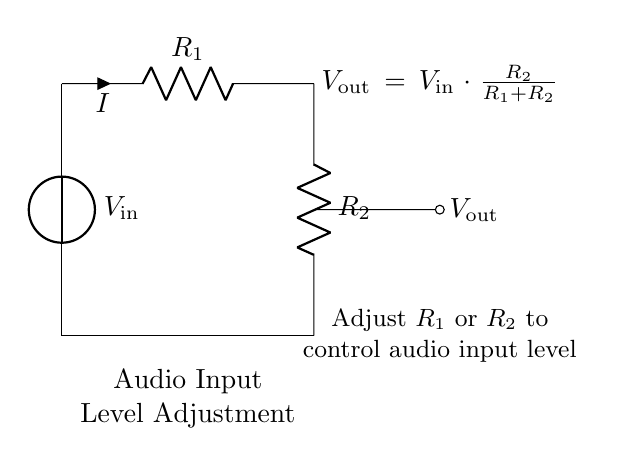What is the role of R1 in the circuit? Resistor R1 is part of the voltage divider that determines the output voltage by working together with R2. It influences how much of the input voltage is dropped across it.
Answer: Resistor What is the output voltage represented in the circuit? The output voltage, Vout, is calculated using the formula Vout = Vin * (R2 / (R1 + R2)), showing its dependence on the values of resistors R1 and R2 relative to Vin.
Answer: Vout What happens to Vout if R2 increases while R1 remains constant? If R2 increases, the proportion of Vout to Vin increases as R2 becomes larger in relation to R1. This raises the output voltage level, which is useful for audio input adjustments.
Answer: Vout increases What is the purpose of this voltage divider circuit? The primary purpose of the voltage divider circuit is to adjust audio input levels, making it suitable for optimizing audio signals before processing them in video editing software.
Answer: Audio adjustment How would you increase the overall output voltage in this circuit? To increase the output voltage, you can either increase R2 or decrease R1, as this change increases the ratio of R2 to the total resistance (R1 + R2).
Answer: Increase R2 or decrease R1 